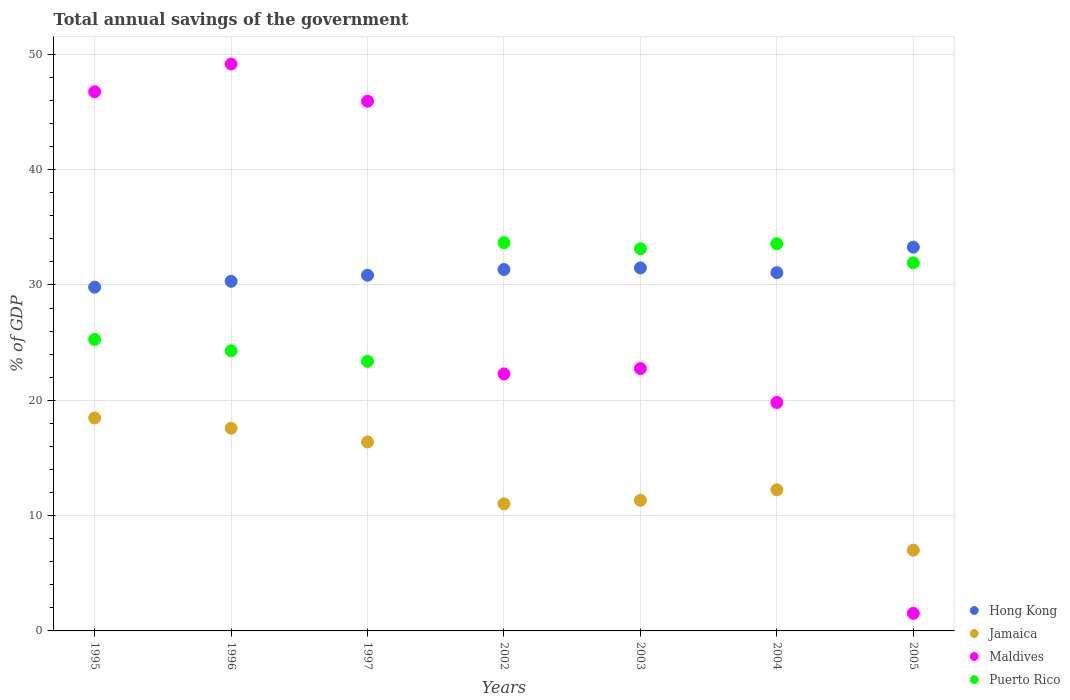How many different coloured dotlines are there?
Offer a terse response. 4. Is the number of dotlines equal to the number of legend labels?
Give a very brief answer. Yes. What is the total annual savings of the government in Puerto Rico in 1996?
Provide a short and direct response. 24.3. Across all years, what is the maximum total annual savings of the government in Jamaica?
Give a very brief answer. 18.47. Across all years, what is the minimum total annual savings of the government in Jamaica?
Your response must be concise. 7. What is the total total annual savings of the government in Maldives in the graph?
Your answer should be compact. 208.21. What is the difference between the total annual savings of the government in Puerto Rico in 1995 and that in 2003?
Make the answer very short. -7.87. What is the difference between the total annual savings of the government in Jamaica in 2004 and the total annual savings of the government in Maldives in 1995?
Give a very brief answer. -34.51. What is the average total annual savings of the government in Maldives per year?
Offer a very short reply. 29.74. In the year 1997, what is the difference between the total annual savings of the government in Jamaica and total annual savings of the government in Maldives?
Offer a very short reply. -29.55. What is the ratio of the total annual savings of the government in Puerto Rico in 2003 to that in 2004?
Your response must be concise. 0.99. What is the difference between the highest and the second highest total annual savings of the government in Maldives?
Offer a terse response. 2.4. What is the difference between the highest and the lowest total annual savings of the government in Puerto Rico?
Make the answer very short. 10.29. Is the sum of the total annual savings of the government in Maldives in 2004 and 2005 greater than the maximum total annual savings of the government in Hong Kong across all years?
Offer a terse response. No. Is it the case that in every year, the sum of the total annual savings of the government in Hong Kong and total annual savings of the government in Puerto Rico  is greater than the sum of total annual savings of the government in Jamaica and total annual savings of the government in Maldives?
Your answer should be compact. Yes. Is it the case that in every year, the sum of the total annual savings of the government in Jamaica and total annual savings of the government in Puerto Rico  is greater than the total annual savings of the government in Hong Kong?
Your answer should be very brief. Yes. Does the total annual savings of the government in Jamaica monotonically increase over the years?
Your answer should be very brief. No. Is the total annual savings of the government in Jamaica strictly greater than the total annual savings of the government in Puerto Rico over the years?
Your response must be concise. No. How many dotlines are there?
Your response must be concise. 4. Are the values on the major ticks of Y-axis written in scientific E-notation?
Ensure brevity in your answer.  No. Does the graph contain grids?
Your response must be concise. Yes. What is the title of the graph?
Provide a succinct answer. Total annual savings of the government. What is the label or title of the X-axis?
Keep it short and to the point. Years. What is the label or title of the Y-axis?
Provide a succinct answer. % of GDP. What is the % of GDP of Hong Kong in 1995?
Provide a succinct answer. 29.81. What is the % of GDP of Jamaica in 1995?
Provide a short and direct response. 18.47. What is the % of GDP in Maldives in 1995?
Your response must be concise. 46.75. What is the % of GDP of Puerto Rico in 1995?
Give a very brief answer. 25.27. What is the % of GDP of Hong Kong in 1996?
Ensure brevity in your answer.  30.32. What is the % of GDP of Jamaica in 1996?
Provide a succinct answer. 17.58. What is the % of GDP of Maldives in 1996?
Provide a short and direct response. 49.15. What is the % of GDP in Puerto Rico in 1996?
Make the answer very short. 24.3. What is the % of GDP of Hong Kong in 1997?
Keep it short and to the point. 30.84. What is the % of GDP in Jamaica in 1997?
Ensure brevity in your answer.  16.39. What is the % of GDP of Maldives in 1997?
Keep it short and to the point. 45.93. What is the % of GDP of Puerto Rico in 1997?
Keep it short and to the point. 23.37. What is the % of GDP of Hong Kong in 2002?
Give a very brief answer. 31.34. What is the % of GDP of Jamaica in 2002?
Make the answer very short. 11.01. What is the % of GDP in Maldives in 2002?
Offer a terse response. 22.29. What is the % of GDP of Puerto Rico in 2002?
Your answer should be compact. 33.66. What is the % of GDP in Hong Kong in 2003?
Give a very brief answer. 31.48. What is the % of GDP of Jamaica in 2003?
Offer a terse response. 11.32. What is the % of GDP in Maldives in 2003?
Give a very brief answer. 22.75. What is the % of GDP in Puerto Rico in 2003?
Your response must be concise. 33.14. What is the % of GDP of Hong Kong in 2004?
Your response must be concise. 31.07. What is the % of GDP of Jamaica in 2004?
Provide a succinct answer. 12.24. What is the % of GDP in Maldives in 2004?
Give a very brief answer. 19.81. What is the % of GDP in Puerto Rico in 2004?
Your answer should be compact. 33.57. What is the % of GDP of Hong Kong in 2005?
Provide a short and direct response. 33.28. What is the % of GDP in Jamaica in 2005?
Ensure brevity in your answer.  7. What is the % of GDP of Maldives in 2005?
Provide a short and direct response. 1.53. What is the % of GDP of Puerto Rico in 2005?
Your response must be concise. 31.92. Across all years, what is the maximum % of GDP in Hong Kong?
Your answer should be very brief. 33.28. Across all years, what is the maximum % of GDP in Jamaica?
Offer a terse response. 18.47. Across all years, what is the maximum % of GDP in Maldives?
Make the answer very short. 49.15. Across all years, what is the maximum % of GDP of Puerto Rico?
Offer a very short reply. 33.66. Across all years, what is the minimum % of GDP of Hong Kong?
Your response must be concise. 29.81. Across all years, what is the minimum % of GDP in Jamaica?
Your answer should be very brief. 7. Across all years, what is the minimum % of GDP of Maldives?
Offer a terse response. 1.53. Across all years, what is the minimum % of GDP of Puerto Rico?
Your response must be concise. 23.37. What is the total % of GDP in Hong Kong in the graph?
Make the answer very short. 218.13. What is the total % of GDP of Jamaica in the graph?
Your response must be concise. 94.01. What is the total % of GDP in Maldives in the graph?
Offer a very short reply. 208.21. What is the total % of GDP of Puerto Rico in the graph?
Provide a succinct answer. 205.24. What is the difference between the % of GDP in Hong Kong in 1995 and that in 1996?
Give a very brief answer. -0.51. What is the difference between the % of GDP of Jamaica in 1995 and that in 1996?
Make the answer very short. 0.89. What is the difference between the % of GDP of Maldives in 1995 and that in 1996?
Offer a very short reply. -2.4. What is the difference between the % of GDP of Puerto Rico in 1995 and that in 1996?
Give a very brief answer. 0.98. What is the difference between the % of GDP in Hong Kong in 1995 and that in 1997?
Your answer should be very brief. -1.03. What is the difference between the % of GDP in Jamaica in 1995 and that in 1997?
Your answer should be compact. 2.08. What is the difference between the % of GDP in Maldives in 1995 and that in 1997?
Give a very brief answer. 0.82. What is the difference between the % of GDP of Puerto Rico in 1995 and that in 1997?
Give a very brief answer. 1.9. What is the difference between the % of GDP of Hong Kong in 1995 and that in 2002?
Offer a terse response. -1.53. What is the difference between the % of GDP of Jamaica in 1995 and that in 2002?
Provide a succinct answer. 7.45. What is the difference between the % of GDP in Maldives in 1995 and that in 2002?
Provide a short and direct response. 24.47. What is the difference between the % of GDP of Puerto Rico in 1995 and that in 2002?
Offer a terse response. -8.39. What is the difference between the % of GDP of Hong Kong in 1995 and that in 2003?
Your response must be concise. -1.67. What is the difference between the % of GDP in Jamaica in 1995 and that in 2003?
Your response must be concise. 7.14. What is the difference between the % of GDP of Maldives in 1995 and that in 2003?
Give a very brief answer. 24.01. What is the difference between the % of GDP in Puerto Rico in 1995 and that in 2003?
Your response must be concise. -7.87. What is the difference between the % of GDP of Hong Kong in 1995 and that in 2004?
Ensure brevity in your answer.  -1.26. What is the difference between the % of GDP of Jamaica in 1995 and that in 2004?
Make the answer very short. 6.23. What is the difference between the % of GDP in Maldives in 1995 and that in 2004?
Ensure brevity in your answer.  26.94. What is the difference between the % of GDP of Puerto Rico in 1995 and that in 2004?
Ensure brevity in your answer.  -8.3. What is the difference between the % of GDP of Hong Kong in 1995 and that in 2005?
Make the answer very short. -3.47. What is the difference between the % of GDP in Jamaica in 1995 and that in 2005?
Your response must be concise. 11.47. What is the difference between the % of GDP of Maldives in 1995 and that in 2005?
Your answer should be compact. 45.22. What is the difference between the % of GDP in Puerto Rico in 1995 and that in 2005?
Offer a terse response. -6.64. What is the difference between the % of GDP of Hong Kong in 1996 and that in 1997?
Your answer should be very brief. -0.53. What is the difference between the % of GDP in Jamaica in 1996 and that in 1997?
Offer a terse response. 1.19. What is the difference between the % of GDP in Maldives in 1996 and that in 1997?
Your answer should be very brief. 3.22. What is the difference between the % of GDP of Puerto Rico in 1996 and that in 1997?
Your response must be concise. 0.92. What is the difference between the % of GDP in Hong Kong in 1996 and that in 2002?
Offer a very short reply. -1.02. What is the difference between the % of GDP of Jamaica in 1996 and that in 2002?
Ensure brevity in your answer.  6.56. What is the difference between the % of GDP in Maldives in 1996 and that in 2002?
Your answer should be compact. 26.87. What is the difference between the % of GDP in Puerto Rico in 1996 and that in 2002?
Your answer should be compact. -9.37. What is the difference between the % of GDP of Hong Kong in 1996 and that in 2003?
Your answer should be very brief. -1.16. What is the difference between the % of GDP of Jamaica in 1996 and that in 2003?
Provide a succinct answer. 6.25. What is the difference between the % of GDP in Maldives in 1996 and that in 2003?
Make the answer very short. 26.41. What is the difference between the % of GDP of Puerto Rico in 1996 and that in 2003?
Your response must be concise. -8.84. What is the difference between the % of GDP in Hong Kong in 1996 and that in 2004?
Provide a succinct answer. -0.75. What is the difference between the % of GDP of Jamaica in 1996 and that in 2004?
Your answer should be compact. 5.34. What is the difference between the % of GDP in Maldives in 1996 and that in 2004?
Provide a short and direct response. 29.35. What is the difference between the % of GDP of Puerto Rico in 1996 and that in 2004?
Give a very brief answer. -9.28. What is the difference between the % of GDP in Hong Kong in 1996 and that in 2005?
Keep it short and to the point. -2.96. What is the difference between the % of GDP in Jamaica in 1996 and that in 2005?
Offer a terse response. 10.58. What is the difference between the % of GDP of Maldives in 1996 and that in 2005?
Your answer should be very brief. 47.63. What is the difference between the % of GDP in Puerto Rico in 1996 and that in 2005?
Provide a short and direct response. -7.62. What is the difference between the % of GDP in Hong Kong in 1997 and that in 2002?
Keep it short and to the point. -0.5. What is the difference between the % of GDP in Jamaica in 1997 and that in 2002?
Ensure brevity in your answer.  5.37. What is the difference between the % of GDP of Maldives in 1997 and that in 2002?
Keep it short and to the point. 23.65. What is the difference between the % of GDP in Puerto Rico in 1997 and that in 2002?
Give a very brief answer. -10.29. What is the difference between the % of GDP of Hong Kong in 1997 and that in 2003?
Your answer should be very brief. -0.63. What is the difference between the % of GDP in Jamaica in 1997 and that in 2003?
Offer a terse response. 5.06. What is the difference between the % of GDP in Maldives in 1997 and that in 2003?
Provide a short and direct response. 23.19. What is the difference between the % of GDP of Puerto Rico in 1997 and that in 2003?
Make the answer very short. -9.76. What is the difference between the % of GDP of Hong Kong in 1997 and that in 2004?
Offer a terse response. -0.23. What is the difference between the % of GDP of Jamaica in 1997 and that in 2004?
Make the answer very short. 4.15. What is the difference between the % of GDP of Maldives in 1997 and that in 2004?
Provide a succinct answer. 26.12. What is the difference between the % of GDP of Puerto Rico in 1997 and that in 2004?
Your response must be concise. -10.2. What is the difference between the % of GDP of Hong Kong in 1997 and that in 2005?
Offer a terse response. -2.43. What is the difference between the % of GDP in Jamaica in 1997 and that in 2005?
Offer a very short reply. 9.39. What is the difference between the % of GDP of Maldives in 1997 and that in 2005?
Your answer should be compact. 44.41. What is the difference between the % of GDP of Puerto Rico in 1997 and that in 2005?
Your answer should be very brief. -8.54. What is the difference between the % of GDP in Hong Kong in 2002 and that in 2003?
Make the answer very short. -0.14. What is the difference between the % of GDP in Jamaica in 2002 and that in 2003?
Keep it short and to the point. -0.31. What is the difference between the % of GDP in Maldives in 2002 and that in 2003?
Provide a short and direct response. -0.46. What is the difference between the % of GDP in Puerto Rico in 2002 and that in 2003?
Make the answer very short. 0.53. What is the difference between the % of GDP of Hong Kong in 2002 and that in 2004?
Your answer should be compact. 0.27. What is the difference between the % of GDP of Jamaica in 2002 and that in 2004?
Keep it short and to the point. -1.22. What is the difference between the % of GDP of Maldives in 2002 and that in 2004?
Give a very brief answer. 2.48. What is the difference between the % of GDP of Puerto Rico in 2002 and that in 2004?
Provide a succinct answer. 0.09. What is the difference between the % of GDP in Hong Kong in 2002 and that in 2005?
Your answer should be compact. -1.94. What is the difference between the % of GDP in Jamaica in 2002 and that in 2005?
Ensure brevity in your answer.  4.01. What is the difference between the % of GDP in Maldives in 2002 and that in 2005?
Give a very brief answer. 20.76. What is the difference between the % of GDP of Puerto Rico in 2002 and that in 2005?
Ensure brevity in your answer.  1.75. What is the difference between the % of GDP of Hong Kong in 2003 and that in 2004?
Ensure brevity in your answer.  0.41. What is the difference between the % of GDP in Jamaica in 2003 and that in 2004?
Your answer should be compact. -0.91. What is the difference between the % of GDP in Maldives in 2003 and that in 2004?
Ensure brevity in your answer.  2.94. What is the difference between the % of GDP of Puerto Rico in 2003 and that in 2004?
Give a very brief answer. -0.43. What is the difference between the % of GDP of Hong Kong in 2003 and that in 2005?
Offer a terse response. -1.8. What is the difference between the % of GDP in Jamaica in 2003 and that in 2005?
Provide a short and direct response. 4.32. What is the difference between the % of GDP of Maldives in 2003 and that in 2005?
Offer a terse response. 21.22. What is the difference between the % of GDP of Puerto Rico in 2003 and that in 2005?
Provide a short and direct response. 1.22. What is the difference between the % of GDP of Hong Kong in 2004 and that in 2005?
Your response must be concise. -2.21. What is the difference between the % of GDP in Jamaica in 2004 and that in 2005?
Make the answer very short. 5.24. What is the difference between the % of GDP in Maldives in 2004 and that in 2005?
Your answer should be very brief. 18.28. What is the difference between the % of GDP in Puerto Rico in 2004 and that in 2005?
Ensure brevity in your answer.  1.65. What is the difference between the % of GDP in Hong Kong in 1995 and the % of GDP in Jamaica in 1996?
Provide a succinct answer. 12.23. What is the difference between the % of GDP of Hong Kong in 1995 and the % of GDP of Maldives in 1996?
Your answer should be compact. -19.35. What is the difference between the % of GDP of Hong Kong in 1995 and the % of GDP of Puerto Rico in 1996?
Give a very brief answer. 5.51. What is the difference between the % of GDP in Jamaica in 1995 and the % of GDP in Maldives in 1996?
Your answer should be very brief. -30.69. What is the difference between the % of GDP of Jamaica in 1995 and the % of GDP of Puerto Rico in 1996?
Your response must be concise. -5.83. What is the difference between the % of GDP in Maldives in 1995 and the % of GDP in Puerto Rico in 1996?
Offer a terse response. 22.45. What is the difference between the % of GDP of Hong Kong in 1995 and the % of GDP of Jamaica in 1997?
Give a very brief answer. 13.42. What is the difference between the % of GDP in Hong Kong in 1995 and the % of GDP in Maldives in 1997?
Your response must be concise. -16.12. What is the difference between the % of GDP of Hong Kong in 1995 and the % of GDP of Puerto Rico in 1997?
Your answer should be compact. 6.44. What is the difference between the % of GDP in Jamaica in 1995 and the % of GDP in Maldives in 1997?
Provide a short and direct response. -27.47. What is the difference between the % of GDP of Jamaica in 1995 and the % of GDP of Puerto Rico in 1997?
Your answer should be very brief. -4.91. What is the difference between the % of GDP in Maldives in 1995 and the % of GDP in Puerto Rico in 1997?
Offer a very short reply. 23.38. What is the difference between the % of GDP in Hong Kong in 1995 and the % of GDP in Jamaica in 2002?
Keep it short and to the point. 18.79. What is the difference between the % of GDP of Hong Kong in 1995 and the % of GDP of Maldives in 2002?
Give a very brief answer. 7.52. What is the difference between the % of GDP of Hong Kong in 1995 and the % of GDP of Puerto Rico in 2002?
Your answer should be compact. -3.86. What is the difference between the % of GDP of Jamaica in 1995 and the % of GDP of Maldives in 2002?
Provide a short and direct response. -3.82. What is the difference between the % of GDP of Jamaica in 1995 and the % of GDP of Puerto Rico in 2002?
Provide a short and direct response. -15.2. What is the difference between the % of GDP in Maldives in 1995 and the % of GDP in Puerto Rico in 2002?
Provide a short and direct response. 13.09. What is the difference between the % of GDP of Hong Kong in 1995 and the % of GDP of Jamaica in 2003?
Offer a terse response. 18.49. What is the difference between the % of GDP of Hong Kong in 1995 and the % of GDP of Maldives in 2003?
Make the answer very short. 7.06. What is the difference between the % of GDP of Hong Kong in 1995 and the % of GDP of Puerto Rico in 2003?
Your answer should be very brief. -3.33. What is the difference between the % of GDP in Jamaica in 1995 and the % of GDP in Maldives in 2003?
Offer a terse response. -4.28. What is the difference between the % of GDP of Jamaica in 1995 and the % of GDP of Puerto Rico in 2003?
Provide a short and direct response. -14.67. What is the difference between the % of GDP of Maldives in 1995 and the % of GDP of Puerto Rico in 2003?
Provide a short and direct response. 13.61. What is the difference between the % of GDP in Hong Kong in 1995 and the % of GDP in Jamaica in 2004?
Provide a succinct answer. 17.57. What is the difference between the % of GDP of Hong Kong in 1995 and the % of GDP of Maldives in 2004?
Provide a succinct answer. 10. What is the difference between the % of GDP in Hong Kong in 1995 and the % of GDP in Puerto Rico in 2004?
Provide a short and direct response. -3.76. What is the difference between the % of GDP of Jamaica in 1995 and the % of GDP of Maldives in 2004?
Your response must be concise. -1.34. What is the difference between the % of GDP of Jamaica in 1995 and the % of GDP of Puerto Rico in 2004?
Offer a very short reply. -15.1. What is the difference between the % of GDP of Maldives in 1995 and the % of GDP of Puerto Rico in 2004?
Provide a succinct answer. 13.18. What is the difference between the % of GDP in Hong Kong in 1995 and the % of GDP in Jamaica in 2005?
Your answer should be compact. 22.81. What is the difference between the % of GDP of Hong Kong in 1995 and the % of GDP of Maldives in 2005?
Your answer should be very brief. 28.28. What is the difference between the % of GDP of Hong Kong in 1995 and the % of GDP of Puerto Rico in 2005?
Your response must be concise. -2.11. What is the difference between the % of GDP of Jamaica in 1995 and the % of GDP of Maldives in 2005?
Ensure brevity in your answer.  16.94. What is the difference between the % of GDP of Jamaica in 1995 and the % of GDP of Puerto Rico in 2005?
Offer a terse response. -13.45. What is the difference between the % of GDP in Maldives in 1995 and the % of GDP in Puerto Rico in 2005?
Offer a very short reply. 14.83. What is the difference between the % of GDP of Hong Kong in 1996 and the % of GDP of Jamaica in 1997?
Provide a succinct answer. 13.93. What is the difference between the % of GDP of Hong Kong in 1996 and the % of GDP of Maldives in 1997?
Offer a terse response. -15.62. What is the difference between the % of GDP of Hong Kong in 1996 and the % of GDP of Puerto Rico in 1997?
Your answer should be compact. 6.94. What is the difference between the % of GDP of Jamaica in 1996 and the % of GDP of Maldives in 1997?
Make the answer very short. -28.36. What is the difference between the % of GDP of Jamaica in 1996 and the % of GDP of Puerto Rico in 1997?
Your answer should be compact. -5.8. What is the difference between the % of GDP in Maldives in 1996 and the % of GDP in Puerto Rico in 1997?
Give a very brief answer. 25.78. What is the difference between the % of GDP of Hong Kong in 1996 and the % of GDP of Jamaica in 2002?
Provide a short and direct response. 19.3. What is the difference between the % of GDP in Hong Kong in 1996 and the % of GDP in Maldives in 2002?
Your answer should be compact. 8.03. What is the difference between the % of GDP of Hong Kong in 1996 and the % of GDP of Puerto Rico in 2002?
Make the answer very short. -3.35. What is the difference between the % of GDP in Jamaica in 1996 and the % of GDP in Maldives in 2002?
Your answer should be compact. -4.71. What is the difference between the % of GDP of Jamaica in 1996 and the % of GDP of Puerto Rico in 2002?
Make the answer very short. -16.09. What is the difference between the % of GDP of Maldives in 1996 and the % of GDP of Puerto Rico in 2002?
Your response must be concise. 15.49. What is the difference between the % of GDP in Hong Kong in 1996 and the % of GDP in Jamaica in 2003?
Make the answer very short. 18.99. What is the difference between the % of GDP of Hong Kong in 1996 and the % of GDP of Maldives in 2003?
Ensure brevity in your answer.  7.57. What is the difference between the % of GDP of Hong Kong in 1996 and the % of GDP of Puerto Rico in 2003?
Your response must be concise. -2.82. What is the difference between the % of GDP in Jamaica in 1996 and the % of GDP in Maldives in 2003?
Provide a short and direct response. -5.17. What is the difference between the % of GDP in Jamaica in 1996 and the % of GDP in Puerto Rico in 2003?
Give a very brief answer. -15.56. What is the difference between the % of GDP in Maldives in 1996 and the % of GDP in Puerto Rico in 2003?
Provide a short and direct response. 16.02. What is the difference between the % of GDP of Hong Kong in 1996 and the % of GDP of Jamaica in 2004?
Provide a succinct answer. 18.08. What is the difference between the % of GDP of Hong Kong in 1996 and the % of GDP of Maldives in 2004?
Keep it short and to the point. 10.51. What is the difference between the % of GDP in Hong Kong in 1996 and the % of GDP in Puerto Rico in 2004?
Provide a short and direct response. -3.26. What is the difference between the % of GDP in Jamaica in 1996 and the % of GDP in Maldives in 2004?
Your answer should be very brief. -2.23. What is the difference between the % of GDP in Jamaica in 1996 and the % of GDP in Puerto Rico in 2004?
Offer a very short reply. -15.99. What is the difference between the % of GDP of Maldives in 1996 and the % of GDP of Puerto Rico in 2004?
Give a very brief answer. 15.58. What is the difference between the % of GDP of Hong Kong in 1996 and the % of GDP of Jamaica in 2005?
Keep it short and to the point. 23.31. What is the difference between the % of GDP in Hong Kong in 1996 and the % of GDP in Maldives in 2005?
Ensure brevity in your answer.  28.79. What is the difference between the % of GDP of Hong Kong in 1996 and the % of GDP of Puerto Rico in 2005?
Offer a very short reply. -1.6. What is the difference between the % of GDP in Jamaica in 1996 and the % of GDP in Maldives in 2005?
Ensure brevity in your answer.  16.05. What is the difference between the % of GDP of Jamaica in 1996 and the % of GDP of Puerto Rico in 2005?
Ensure brevity in your answer.  -14.34. What is the difference between the % of GDP of Maldives in 1996 and the % of GDP of Puerto Rico in 2005?
Provide a short and direct response. 17.24. What is the difference between the % of GDP in Hong Kong in 1997 and the % of GDP in Jamaica in 2002?
Provide a short and direct response. 19.83. What is the difference between the % of GDP of Hong Kong in 1997 and the % of GDP of Maldives in 2002?
Give a very brief answer. 8.56. What is the difference between the % of GDP of Hong Kong in 1997 and the % of GDP of Puerto Rico in 2002?
Keep it short and to the point. -2.82. What is the difference between the % of GDP in Jamaica in 1997 and the % of GDP in Maldives in 2002?
Keep it short and to the point. -5.9. What is the difference between the % of GDP of Jamaica in 1997 and the % of GDP of Puerto Rico in 2002?
Give a very brief answer. -17.28. What is the difference between the % of GDP of Maldives in 1997 and the % of GDP of Puerto Rico in 2002?
Ensure brevity in your answer.  12.27. What is the difference between the % of GDP in Hong Kong in 1997 and the % of GDP in Jamaica in 2003?
Ensure brevity in your answer.  19.52. What is the difference between the % of GDP in Hong Kong in 1997 and the % of GDP in Maldives in 2003?
Provide a succinct answer. 8.1. What is the difference between the % of GDP of Hong Kong in 1997 and the % of GDP of Puerto Rico in 2003?
Your answer should be very brief. -2.3. What is the difference between the % of GDP of Jamaica in 1997 and the % of GDP of Maldives in 2003?
Provide a succinct answer. -6.36. What is the difference between the % of GDP of Jamaica in 1997 and the % of GDP of Puerto Rico in 2003?
Provide a short and direct response. -16.75. What is the difference between the % of GDP in Maldives in 1997 and the % of GDP in Puerto Rico in 2003?
Provide a short and direct response. 12.8. What is the difference between the % of GDP of Hong Kong in 1997 and the % of GDP of Jamaica in 2004?
Ensure brevity in your answer.  18.61. What is the difference between the % of GDP in Hong Kong in 1997 and the % of GDP in Maldives in 2004?
Keep it short and to the point. 11.03. What is the difference between the % of GDP of Hong Kong in 1997 and the % of GDP of Puerto Rico in 2004?
Give a very brief answer. -2.73. What is the difference between the % of GDP in Jamaica in 1997 and the % of GDP in Maldives in 2004?
Ensure brevity in your answer.  -3.42. What is the difference between the % of GDP of Jamaica in 1997 and the % of GDP of Puerto Rico in 2004?
Provide a short and direct response. -17.19. What is the difference between the % of GDP in Maldives in 1997 and the % of GDP in Puerto Rico in 2004?
Provide a succinct answer. 12.36. What is the difference between the % of GDP of Hong Kong in 1997 and the % of GDP of Jamaica in 2005?
Ensure brevity in your answer.  23.84. What is the difference between the % of GDP in Hong Kong in 1997 and the % of GDP in Maldives in 2005?
Provide a succinct answer. 29.32. What is the difference between the % of GDP of Hong Kong in 1997 and the % of GDP of Puerto Rico in 2005?
Provide a short and direct response. -1.08. What is the difference between the % of GDP in Jamaica in 1997 and the % of GDP in Maldives in 2005?
Provide a short and direct response. 14.86. What is the difference between the % of GDP of Jamaica in 1997 and the % of GDP of Puerto Rico in 2005?
Give a very brief answer. -15.53. What is the difference between the % of GDP of Maldives in 1997 and the % of GDP of Puerto Rico in 2005?
Offer a terse response. 14.02. What is the difference between the % of GDP in Hong Kong in 2002 and the % of GDP in Jamaica in 2003?
Make the answer very short. 20.01. What is the difference between the % of GDP in Hong Kong in 2002 and the % of GDP in Maldives in 2003?
Your answer should be very brief. 8.59. What is the difference between the % of GDP in Hong Kong in 2002 and the % of GDP in Puerto Rico in 2003?
Your answer should be compact. -1.8. What is the difference between the % of GDP in Jamaica in 2002 and the % of GDP in Maldives in 2003?
Offer a very short reply. -11.73. What is the difference between the % of GDP in Jamaica in 2002 and the % of GDP in Puerto Rico in 2003?
Keep it short and to the point. -22.12. What is the difference between the % of GDP of Maldives in 2002 and the % of GDP of Puerto Rico in 2003?
Make the answer very short. -10.85. What is the difference between the % of GDP of Hong Kong in 2002 and the % of GDP of Jamaica in 2004?
Make the answer very short. 19.1. What is the difference between the % of GDP in Hong Kong in 2002 and the % of GDP in Maldives in 2004?
Provide a short and direct response. 11.53. What is the difference between the % of GDP in Hong Kong in 2002 and the % of GDP in Puerto Rico in 2004?
Provide a succinct answer. -2.23. What is the difference between the % of GDP of Jamaica in 2002 and the % of GDP of Maldives in 2004?
Provide a short and direct response. -8.79. What is the difference between the % of GDP in Jamaica in 2002 and the % of GDP in Puerto Rico in 2004?
Provide a succinct answer. -22.56. What is the difference between the % of GDP in Maldives in 2002 and the % of GDP in Puerto Rico in 2004?
Offer a terse response. -11.29. What is the difference between the % of GDP in Hong Kong in 2002 and the % of GDP in Jamaica in 2005?
Your answer should be very brief. 24.34. What is the difference between the % of GDP of Hong Kong in 2002 and the % of GDP of Maldives in 2005?
Your answer should be compact. 29.81. What is the difference between the % of GDP of Hong Kong in 2002 and the % of GDP of Puerto Rico in 2005?
Ensure brevity in your answer.  -0.58. What is the difference between the % of GDP of Jamaica in 2002 and the % of GDP of Maldives in 2005?
Ensure brevity in your answer.  9.49. What is the difference between the % of GDP of Jamaica in 2002 and the % of GDP of Puerto Rico in 2005?
Provide a short and direct response. -20.9. What is the difference between the % of GDP in Maldives in 2002 and the % of GDP in Puerto Rico in 2005?
Make the answer very short. -9.63. What is the difference between the % of GDP in Hong Kong in 2003 and the % of GDP in Jamaica in 2004?
Provide a succinct answer. 19.24. What is the difference between the % of GDP of Hong Kong in 2003 and the % of GDP of Maldives in 2004?
Your answer should be compact. 11.67. What is the difference between the % of GDP in Hong Kong in 2003 and the % of GDP in Puerto Rico in 2004?
Offer a terse response. -2.1. What is the difference between the % of GDP in Jamaica in 2003 and the % of GDP in Maldives in 2004?
Offer a very short reply. -8.49. What is the difference between the % of GDP of Jamaica in 2003 and the % of GDP of Puerto Rico in 2004?
Your answer should be compact. -22.25. What is the difference between the % of GDP in Maldives in 2003 and the % of GDP in Puerto Rico in 2004?
Provide a short and direct response. -10.83. What is the difference between the % of GDP of Hong Kong in 2003 and the % of GDP of Jamaica in 2005?
Keep it short and to the point. 24.48. What is the difference between the % of GDP in Hong Kong in 2003 and the % of GDP in Maldives in 2005?
Provide a short and direct response. 29.95. What is the difference between the % of GDP in Hong Kong in 2003 and the % of GDP in Puerto Rico in 2005?
Provide a short and direct response. -0.44. What is the difference between the % of GDP of Jamaica in 2003 and the % of GDP of Maldives in 2005?
Offer a very short reply. 9.8. What is the difference between the % of GDP in Jamaica in 2003 and the % of GDP in Puerto Rico in 2005?
Provide a short and direct response. -20.59. What is the difference between the % of GDP of Maldives in 2003 and the % of GDP of Puerto Rico in 2005?
Your answer should be compact. -9.17. What is the difference between the % of GDP of Hong Kong in 2004 and the % of GDP of Jamaica in 2005?
Your answer should be very brief. 24.07. What is the difference between the % of GDP in Hong Kong in 2004 and the % of GDP in Maldives in 2005?
Your answer should be compact. 29.54. What is the difference between the % of GDP of Hong Kong in 2004 and the % of GDP of Puerto Rico in 2005?
Offer a very short reply. -0.85. What is the difference between the % of GDP in Jamaica in 2004 and the % of GDP in Maldives in 2005?
Keep it short and to the point. 10.71. What is the difference between the % of GDP in Jamaica in 2004 and the % of GDP in Puerto Rico in 2005?
Your answer should be very brief. -19.68. What is the difference between the % of GDP of Maldives in 2004 and the % of GDP of Puerto Rico in 2005?
Give a very brief answer. -12.11. What is the average % of GDP of Hong Kong per year?
Ensure brevity in your answer.  31.16. What is the average % of GDP in Jamaica per year?
Your answer should be very brief. 13.43. What is the average % of GDP in Maldives per year?
Keep it short and to the point. 29.74. What is the average % of GDP in Puerto Rico per year?
Your answer should be compact. 29.32. In the year 1995, what is the difference between the % of GDP of Hong Kong and % of GDP of Jamaica?
Offer a very short reply. 11.34. In the year 1995, what is the difference between the % of GDP of Hong Kong and % of GDP of Maldives?
Your answer should be very brief. -16.94. In the year 1995, what is the difference between the % of GDP in Hong Kong and % of GDP in Puerto Rico?
Offer a very short reply. 4.54. In the year 1995, what is the difference between the % of GDP of Jamaica and % of GDP of Maldives?
Make the answer very short. -28.28. In the year 1995, what is the difference between the % of GDP in Jamaica and % of GDP in Puerto Rico?
Keep it short and to the point. -6.8. In the year 1995, what is the difference between the % of GDP of Maldives and % of GDP of Puerto Rico?
Ensure brevity in your answer.  21.48. In the year 1996, what is the difference between the % of GDP in Hong Kong and % of GDP in Jamaica?
Ensure brevity in your answer.  12.74. In the year 1996, what is the difference between the % of GDP of Hong Kong and % of GDP of Maldives?
Your response must be concise. -18.84. In the year 1996, what is the difference between the % of GDP in Hong Kong and % of GDP in Puerto Rico?
Offer a very short reply. 6.02. In the year 1996, what is the difference between the % of GDP in Jamaica and % of GDP in Maldives?
Your answer should be very brief. -31.58. In the year 1996, what is the difference between the % of GDP of Jamaica and % of GDP of Puerto Rico?
Ensure brevity in your answer.  -6.72. In the year 1996, what is the difference between the % of GDP in Maldives and % of GDP in Puerto Rico?
Make the answer very short. 24.86. In the year 1997, what is the difference between the % of GDP in Hong Kong and % of GDP in Jamaica?
Give a very brief answer. 14.46. In the year 1997, what is the difference between the % of GDP in Hong Kong and % of GDP in Maldives?
Give a very brief answer. -15.09. In the year 1997, what is the difference between the % of GDP of Hong Kong and % of GDP of Puerto Rico?
Your answer should be compact. 7.47. In the year 1997, what is the difference between the % of GDP of Jamaica and % of GDP of Maldives?
Keep it short and to the point. -29.55. In the year 1997, what is the difference between the % of GDP of Jamaica and % of GDP of Puerto Rico?
Give a very brief answer. -6.99. In the year 1997, what is the difference between the % of GDP of Maldives and % of GDP of Puerto Rico?
Your response must be concise. 22.56. In the year 2002, what is the difference between the % of GDP in Hong Kong and % of GDP in Jamaica?
Your answer should be compact. 20.32. In the year 2002, what is the difference between the % of GDP of Hong Kong and % of GDP of Maldives?
Make the answer very short. 9.05. In the year 2002, what is the difference between the % of GDP of Hong Kong and % of GDP of Puerto Rico?
Give a very brief answer. -2.33. In the year 2002, what is the difference between the % of GDP in Jamaica and % of GDP in Maldives?
Keep it short and to the point. -11.27. In the year 2002, what is the difference between the % of GDP of Jamaica and % of GDP of Puerto Rico?
Ensure brevity in your answer.  -22.65. In the year 2002, what is the difference between the % of GDP in Maldives and % of GDP in Puerto Rico?
Give a very brief answer. -11.38. In the year 2003, what is the difference between the % of GDP in Hong Kong and % of GDP in Jamaica?
Your answer should be compact. 20.15. In the year 2003, what is the difference between the % of GDP in Hong Kong and % of GDP in Maldives?
Offer a terse response. 8.73. In the year 2003, what is the difference between the % of GDP of Hong Kong and % of GDP of Puerto Rico?
Your answer should be very brief. -1.66. In the year 2003, what is the difference between the % of GDP in Jamaica and % of GDP in Maldives?
Make the answer very short. -11.42. In the year 2003, what is the difference between the % of GDP of Jamaica and % of GDP of Puerto Rico?
Your answer should be compact. -21.81. In the year 2003, what is the difference between the % of GDP in Maldives and % of GDP in Puerto Rico?
Offer a terse response. -10.39. In the year 2004, what is the difference between the % of GDP in Hong Kong and % of GDP in Jamaica?
Offer a terse response. 18.83. In the year 2004, what is the difference between the % of GDP of Hong Kong and % of GDP of Maldives?
Keep it short and to the point. 11.26. In the year 2004, what is the difference between the % of GDP of Hong Kong and % of GDP of Puerto Rico?
Keep it short and to the point. -2.5. In the year 2004, what is the difference between the % of GDP in Jamaica and % of GDP in Maldives?
Provide a succinct answer. -7.57. In the year 2004, what is the difference between the % of GDP of Jamaica and % of GDP of Puerto Rico?
Ensure brevity in your answer.  -21.34. In the year 2004, what is the difference between the % of GDP in Maldives and % of GDP in Puerto Rico?
Offer a terse response. -13.76. In the year 2005, what is the difference between the % of GDP in Hong Kong and % of GDP in Jamaica?
Offer a terse response. 26.28. In the year 2005, what is the difference between the % of GDP in Hong Kong and % of GDP in Maldives?
Offer a terse response. 31.75. In the year 2005, what is the difference between the % of GDP of Hong Kong and % of GDP of Puerto Rico?
Ensure brevity in your answer.  1.36. In the year 2005, what is the difference between the % of GDP in Jamaica and % of GDP in Maldives?
Your answer should be very brief. 5.47. In the year 2005, what is the difference between the % of GDP in Jamaica and % of GDP in Puerto Rico?
Provide a short and direct response. -24.92. In the year 2005, what is the difference between the % of GDP of Maldives and % of GDP of Puerto Rico?
Offer a very short reply. -30.39. What is the ratio of the % of GDP in Hong Kong in 1995 to that in 1996?
Your answer should be very brief. 0.98. What is the ratio of the % of GDP in Jamaica in 1995 to that in 1996?
Offer a terse response. 1.05. What is the ratio of the % of GDP of Maldives in 1995 to that in 1996?
Make the answer very short. 0.95. What is the ratio of the % of GDP of Puerto Rico in 1995 to that in 1996?
Make the answer very short. 1.04. What is the ratio of the % of GDP in Hong Kong in 1995 to that in 1997?
Give a very brief answer. 0.97. What is the ratio of the % of GDP in Jamaica in 1995 to that in 1997?
Your response must be concise. 1.13. What is the ratio of the % of GDP in Maldives in 1995 to that in 1997?
Your response must be concise. 1.02. What is the ratio of the % of GDP in Puerto Rico in 1995 to that in 1997?
Ensure brevity in your answer.  1.08. What is the ratio of the % of GDP in Hong Kong in 1995 to that in 2002?
Offer a terse response. 0.95. What is the ratio of the % of GDP in Jamaica in 1995 to that in 2002?
Give a very brief answer. 1.68. What is the ratio of the % of GDP of Maldives in 1995 to that in 2002?
Your response must be concise. 2.1. What is the ratio of the % of GDP of Puerto Rico in 1995 to that in 2002?
Give a very brief answer. 0.75. What is the ratio of the % of GDP of Hong Kong in 1995 to that in 2003?
Keep it short and to the point. 0.95. What is the ratio of the % of GDP of Jamaica in 1995 to that in 2003?
Provide a short and direct response. 1.63. What is the ratio of the % of GDP of Maldives in 1995 to that in 2003?
Your answer should be compact. 2.06. What is the ratio of the % of GDP in Puerto Rico in 1995 to that in 2003?
Provide a short and direct response. 0.76. What is the ratio of the % of GDP of Hong Kong in 1995 to that in 2004?
Your answer should be compact. 0.96. What is the ratio of the % of GDP in Jamaica in 1995 to that in 2004?
Keep it short and to the point. 1.51. What is the ratio of the % of GDP in Maldives in 1995 to that in 2004?
Give a very brief answer. 2.36. What is the ratio of the % of GDP of Puerto Rico in 1995 to that in 2004?
Provide a short and direct response. 0.75. What is the ratio of the % of GDP in Hong Kong in 1995 to that in 2005?
Provide a succinct answer. 0.9. What is the ratio of the % of GDP in Jamaica in 1995 to that in 2005?
Your answer should be very brief. 2.64. What is the ratio of the % of GDP of Maldives in 1995 to that in 2005?
Provide a succinct answer. 30.61. What is the ratio of the % of GDP in Puerto Rico in 1995 to that in 2005?
Your answer should be very brief. 0.79. What is the ratio of the % of GDP in Hong Kong in 1996 to that in 1997?
Keep it short and to the point. 0.98. What is the ratio of the % of GDP of Jamaica in 1996 to that in 1997?
Keep it short and to the point. 1.07. What is the ratio of the % of GDP of Maldives in 1996 to that in 1997?
Provide a short and direct response. 1.07. What is the ratio of the % of GDP in Puerto Rico in 1996 to that in 1997?
Provide a succinct answer. 1.04. What is the ratio of the % of GDP in Hong Kong in 1996 to that in 2002?
Give a very brief answer. 0.97. What is the ratio of the % of GDP of Jamaica in 1996 to that in 2002?
Offer a very short reply. 1.6. What is the ratio of the % of GDP in Maldives in 1996 to that in 2002?
Offer a terse response. 2.21. What is the ratio of the % of GDP of Puerto Rico in 1996 to that in 2002?
Keep it short and to the point. 0.72. What is the ratio of the % of GDP of Hong Kong in 1996 to that in 2003?
Offer a terse response. 0.96. What is the ratio of the % of GDP in Jamaica in 1996 to that in 2003?
Ensure brevity in your answer.  1.55. What is the ratio of the % of GDP in Maldives in 1996 to that in 2003?
Give a very brief answer. 2.16. What is the ratio of the % of GDP in Puerto Rico in 1996 to that in 2003?
Keep it short and to the point. 0.73. What is the ratio of the % of GDP in Hong Kong in 1996 to that in 2004?
Offer a terse response. 0.98. What is the ratio of the % of GDP in Jamaica in 1996 to that in 2004?
Ensure brevity in your answer.  1.44. What is the ratio of the % of GDP in Maldives in 1996 to that in 2004?
Provide a short and direct response. 2.48. What is the ratio of the % of GDP of Puerto Rico in 1996 to that in 2004?
Make the answer very short. 0.72. What is the ratio of the % of GDP of Hong Kong in 1996 to that in 2005?
Provide a short and direct response. 0.91. What is the ratio of the % of GDP of Jamaica in 1996 to that in 2005?
Offer a very short reply. 2.51. What is the ratio of the % of GDP in Maldives in 1996 to that in 2005?
Provide a short and direct response. 32.19. What is the ratio of the % of GDP of Puerto Rico in 1996 to that in 2005?
Make the answer very short. 0.76. What is the ratio of the % of GDP of Hong Kong in 1997 to that in 2002?
Provide a short and direct response. 0.98. What is the ratio of the % of GDP of Jamaica in 1997 to that in 2002?
Offer a terse response. 1.49. What is the ratio of the % of GDP in Maldives in 1997 to that in 2002?
Offer a terse response. 2.06. What is the ratio of the % of GDP of Puerto Rico in 1997 to that in 2002?
Ensure brevity in your answer.  0.69. What is the ratio of the % of GDP in Hong Kong in 1997 to that in 2003?
Keep it short and to the point. 0.98. What is the ratio of the % of GDP in Jamaica in 1997 to that in 2003?
Offer a terse response. 1.45. What is the ratio of the % of GDP of Maldives in 1997 to that in 2003?
Offer a terse response. 2.02. What is the ratio of the % of GDP of Puerto Rico in 1997 to that in 2003?
Your answer should be very brief. 0.71. What is the ratio of the % of GDP of Hong Kong in 1997 to that in 2004?
Your response must be concise. 0.99. What is the ratio of the % of GDP in Jamaica in 1997 to that in 2004?
Your answer should be very brief. 1.34. What is the ratio of the % of GDP in Maldives in 1997 to that in 2004?
Give a very brief answer. 2.32. What is the ratio of the % of GDP of Puerto Rico in 1997 to that in 2004?
Offer a terse response. 0.7. What is the ratio of the % of GDP in Hong Kong in 1997 to that in 2005?
Offer a very short reply. 0.93. What is the ratio of the % of GDP of Jamaica in 1997 to that in 2005?
Offer a terse response. 2.34. What is the ratio of the % of GDP of Maldives in 1997 to that in 2005?
Give a very brief answer. 30.08. What is the ratio of the % of GDP of Puerto Rico in 1997 to that in 2005?
Make the answer very short. 0.73. What is the ratio of the % of GDP in Hong Kong in 2002 to that in 2003?
Provide a succinct answer. 1. What is the ratio of the % of GDP in Jamaica in 2002 to that in 2003?
Your response must be concise. 0.97. What is the ratio of the % of GDP in Maldives in 2002 to that in 2003?
Provide a succinct answer. 0.98. What is the ratio of the % of GDP in Puerto Rico in 2002 to that in 2003?
Your response must be concise. 1.02. What is the ratio of the % of GDP of Hong Kong in 2002 to that in 2004?
Offer a very short reply. 1.01. What is the ratio of the % of GDP in Jamaica in 2002 to that in 2004?
Your answer should be compact. 0.9. What is the ratio of the % of GDP of Maldives in 2002 to that in 2004?
Make the answer very short. 1.12. What is the ratio of the % of GDP in Hong Kong in 2002 to that in 2005?
Offer a very short reply. 0.94. What is the ratio of the % of GDP of Jamaica in 2002 to that in 2005?
Give a very brief answer. 1.57. What is the ratio of the % of GDP of Maldives in 2002 to that in 2005?
Your answer should be compact. 14.59. What is the ratio of the % of GDP of Puerto Rico in 2002 to that in 2005?
Ensure brevity in your answer.  1.05. What is the ratio of the % of GDP in Hong Kong in 2003 to that in 2004?
Offer a very short reply. 1.01. What is the ratio of the % of GDP in Jamaica in 2003 to that in 2004?
Ensure brevity in your answer.  0.93. What is the ratio of the % of GDP in Maldives in 2003 to that in 2004?
Provide a short and direct response. 1.15. What is the ratio of the % of GDP in Puerto Rico in 2003 to that in 2004?
Keep it short and to the point. 0.99. What is the ratio of the % of GDP in Hong Kong in 2003 to that in 2005?
Offer a terse response. 0.95. What is the ratio of the % of GDP of Jamaica in 2003 to that in 2005?
Give a very brief answer. 1.62. What is the ratio of the % of GDP of Maldives in 2003 to that in 2005?
Ensure brevity in your answer.  14.89. What is the ratio of the % of GDP in Puerto Rico in 2003 to that in 2005?
Ensure brevity in your answer.  1.04. What is the ratio of the % of GDP in Hong Kong in 2004 to that in 2005?
Ensure brevity in your answer.  0.93. What is the ratio of the % of GDP in Jamaica in 2004 to that in 2005?
Make the answer very short. 1.75. What is the ratio of the % of GDP in Maldives in 2004 to that in 2005?
Make the answer very short. 12.97. What is the ratio of the % of GDP in Puerto Rico in 2004 to that in 2005?
Keep it short and to the point. 1.05. What is the difference between the highest and the second highest % of GDP in Hong Kong?
Provide a succinct answer. 1.8. What is the difference between the highest and the second highest % of GDP in Jamaica?
Provide a succinct answer. 0.89. What is the difference between the highest and the second highest % of GDP in Maldives?
Your answer should be very brief. 2.4. What is the difference between the highest and the second highest % of GDP in Puerto Rico?
Keep it short and to the point. 0.09. What is the difference between the highest and the lowest % of GDP in Hong Kong?
Make the answer very short. 3.47. What is the difference between the highest and the lowest % of GDP in Jamaica?
Offer a very short reply. 11.47. What is the difference between the highest and the lowest % of GDP in Maldives?
Provide a succinct answer. 47.63. What is the difference between the highest and the lowest % of GDP of Puerto Rico?
Make the answer very short. 10.29. 